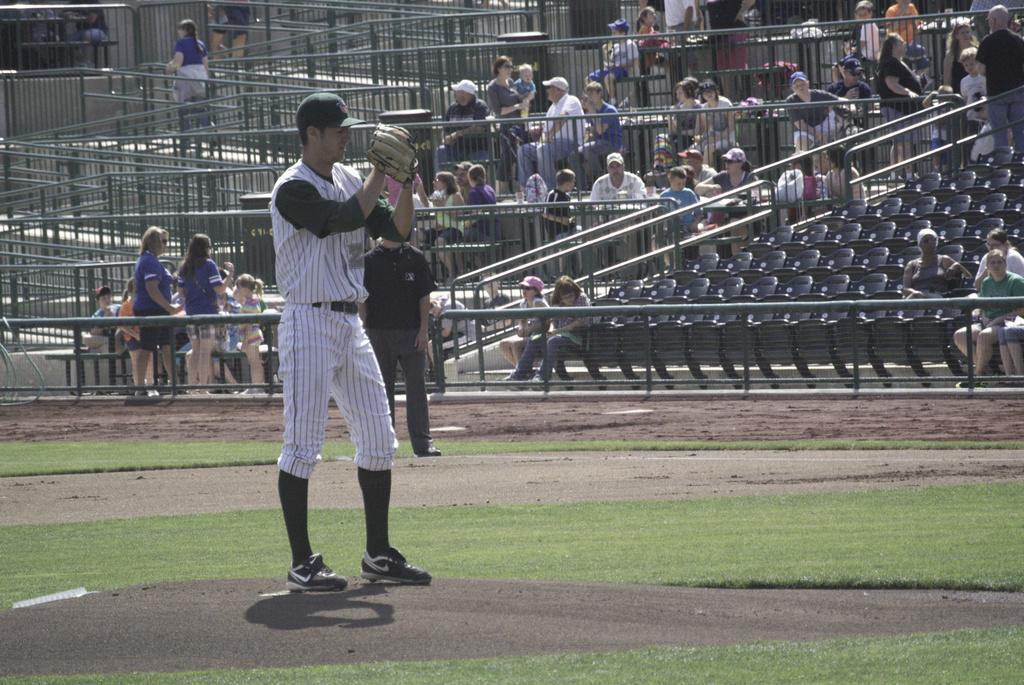Can you describe this image briefly? In a ground there are two men,they are playing baseball and behind the ground there are spectators watching the match. 